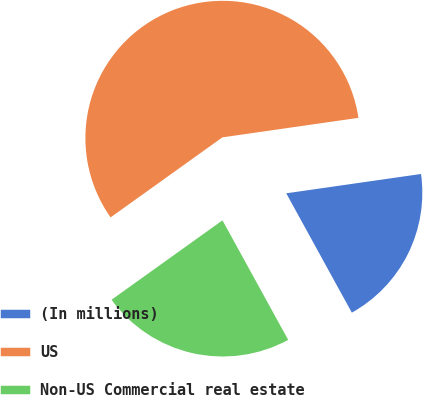Convert chart to OTSL. <chart><loc_0><loc_0><loc_500><loc_500><pie_chart><fcel>(In millions)<fcel>US<fcel>Non-US Commercial real estate<nl><fcel>19.27%<fcel>57.62%<fcel>23.11%<nl></chart> 